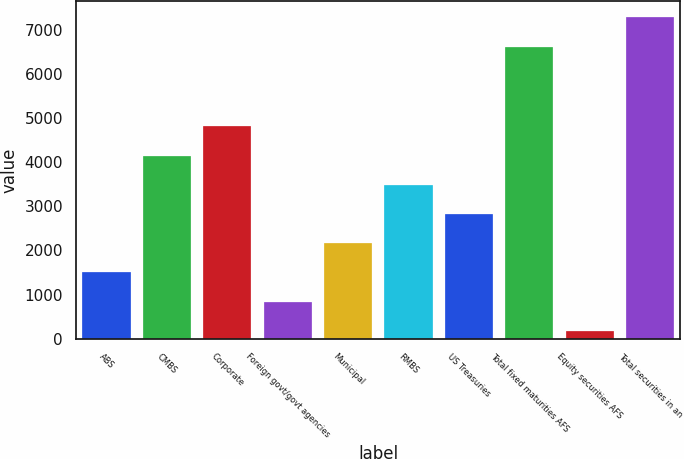Convert chart to OTSL. <chart><loc_0><loc_0><loc_500><loc_500><bar_chart><fcel>ABS<fcel>CMBS<fcel>Corporate<fcel>Foreign govt/govt agencies<fcel>Municipal<fcel>RMBS<fcel>US Treasuries<fcel>Total fixed maturities AFS<fcel>Equity securities AFS<fcel>Total securities in an<nl><fcel>1500.4<fcel>4149.2<fcel>4811.4<fcel>838.2<fcel>2162.6<fcel>3487<fcel>2824.8<fcel>6622<fcel>176<fcel>7284.2<nl></chart> 